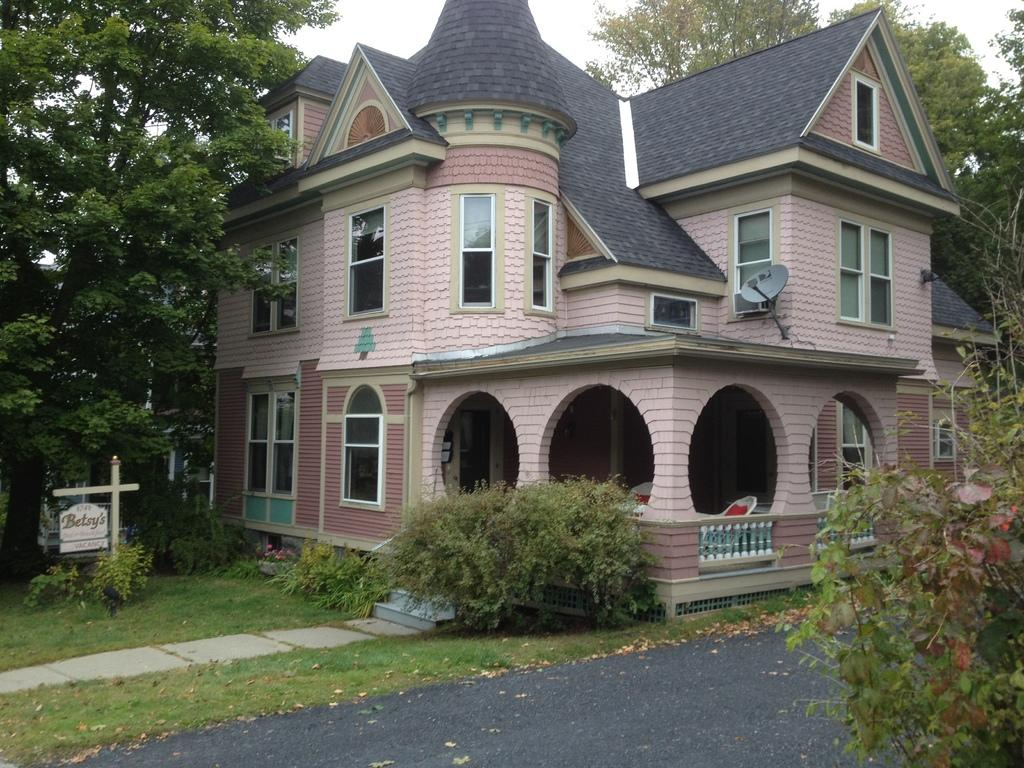What type of structure is visible in the image? There is a building in the image. What feature of the building is mentioned in the facts? The building has windows. What architectural element can be seen in the image? There are stairs in the image. What other objects are present in the image? There is a fence, a pole, a board, a road, grass, a plant, and trees in the image. What is the color of the sky in the image? The sky is white in the image. What type of oil can be seen dripping from the trees in the image? There is no oil present in the image; only trees are mentioned. Are there any bears visible in the image? There are no bears present in the image. 